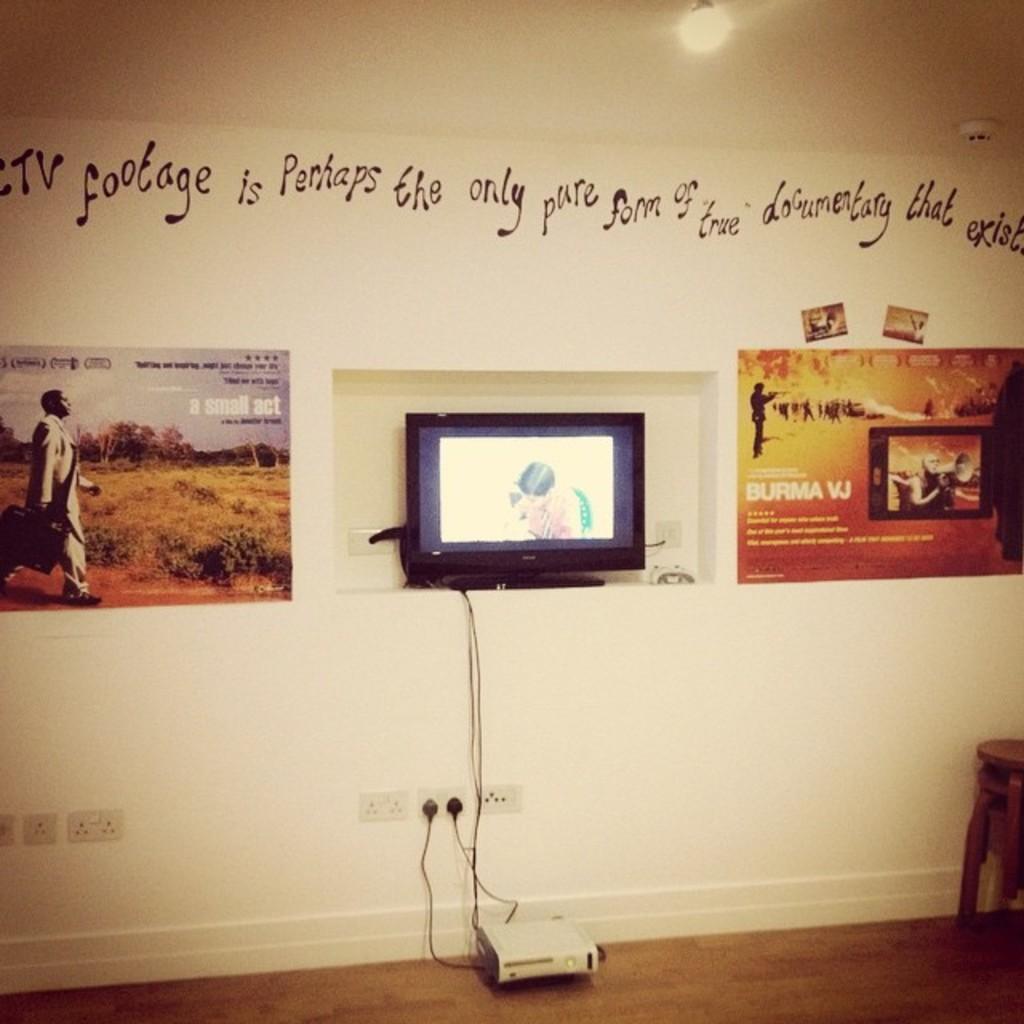In one or two sentences, can you explain what this image depicts? In this image we can see a wall, there is a television, and there are wires, beside there are posters, and at above there is something written on the wall, there is a stool, at the top there is a light. 